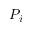Convert formula to latex. <formula><loc_0><loc_0><loc_500><loc_500>P _ { i }</formula> 